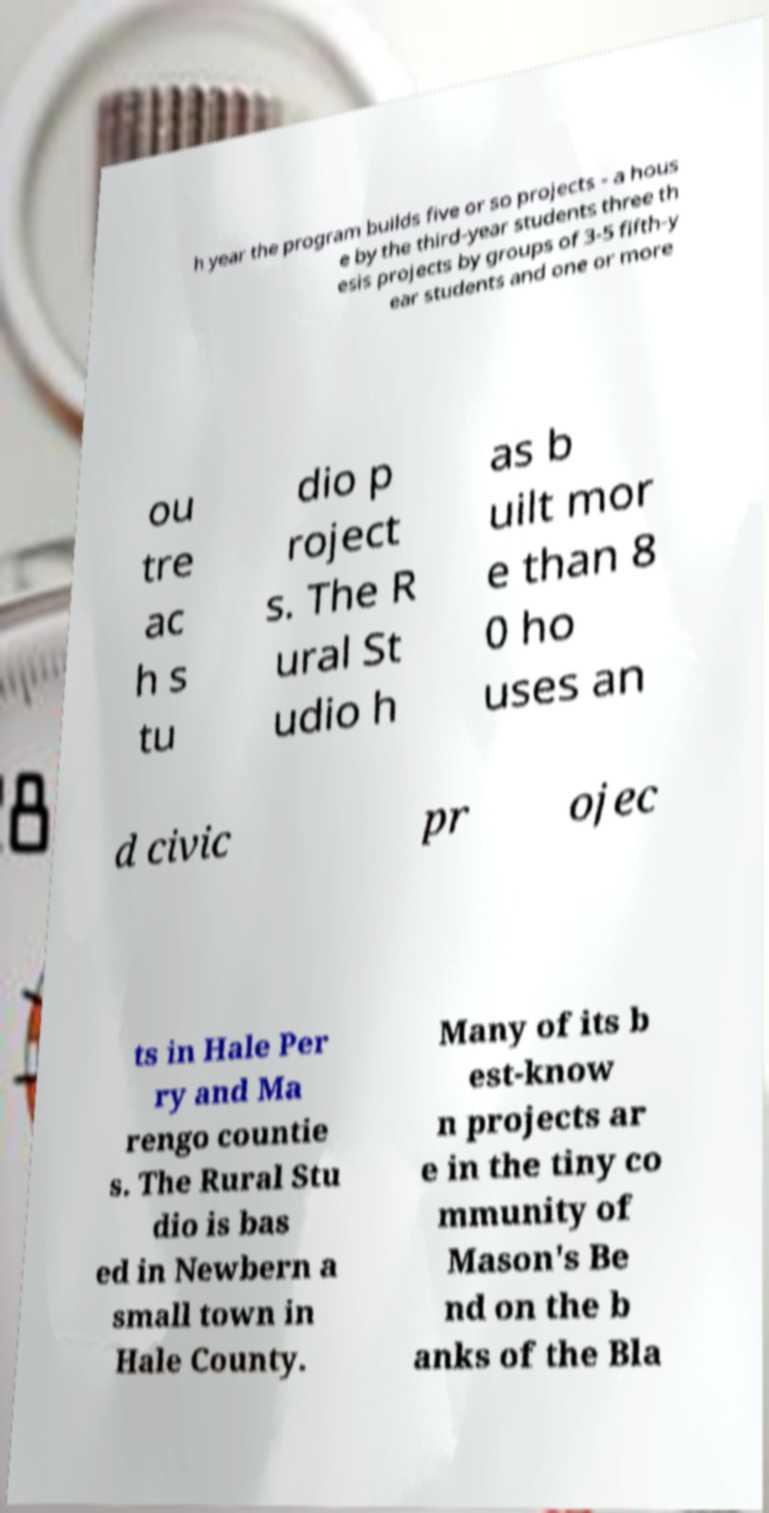Could you assist in decoding the text presented in this image and type it out clearly? h year the program builds five or so projects - a hous e by the third-year students three th esis projects by groups of 3-5 fifth-y ear students and one or more ou tre ac h s tu dio p roject s. The R ural St udio h as b uilt mor e than 8 0 ho uses an d civic pr ojec ts in Hale Per ry and Ma rengo countie s. The Rural Stu dio is bas ed in Newbern a small town in Hale County. Many of its b est-know n projects ar e in the tiny co mmunity of Mason's Be nd on the b anks of the Bla 